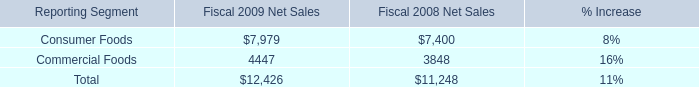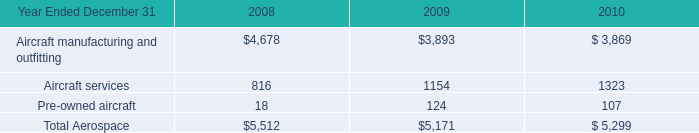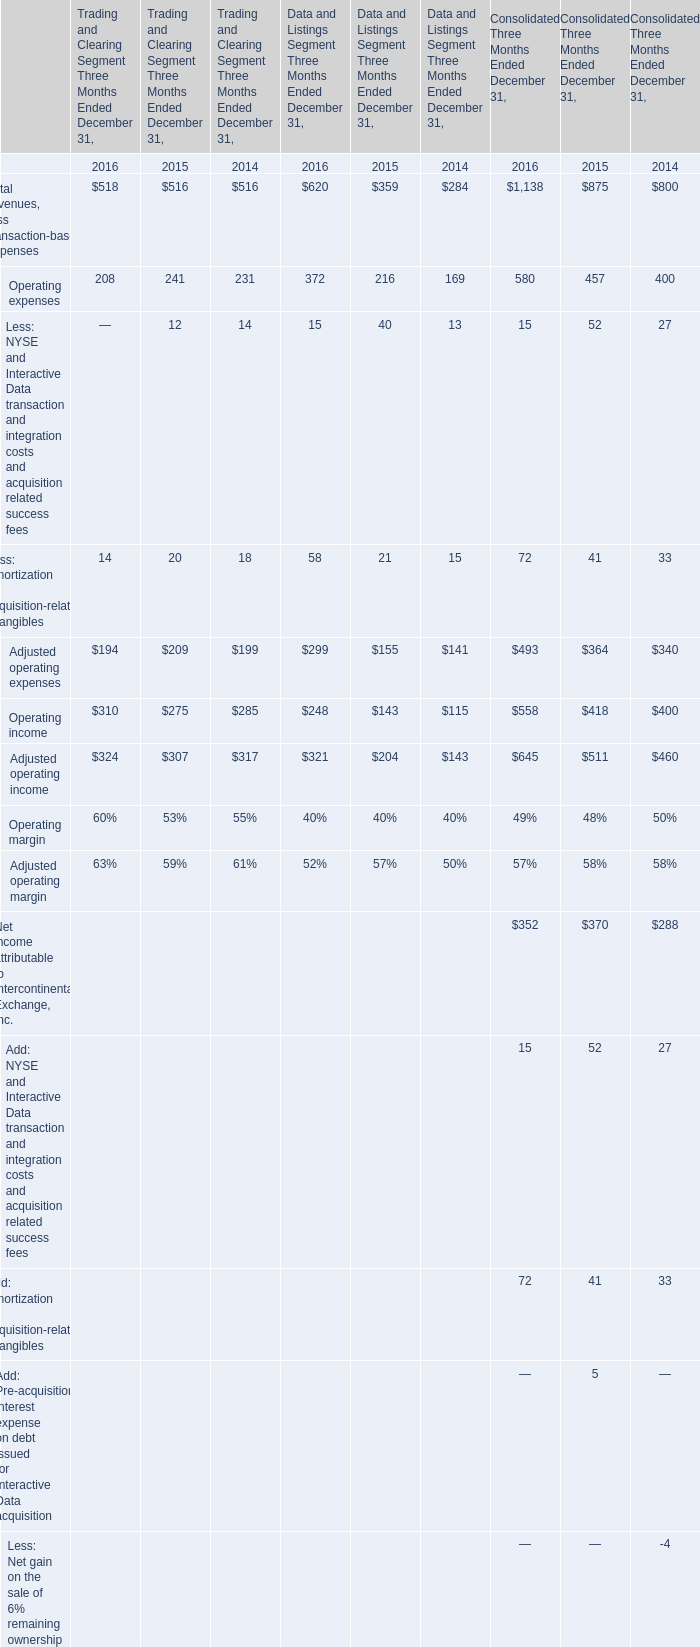What is the sum of Operating income of Trading and Clearing Segment Three Months Ended December 31 in 2016 and Aircraft services in 2008? 
Computations: (310 + 816)
Answer: 1126.0. 